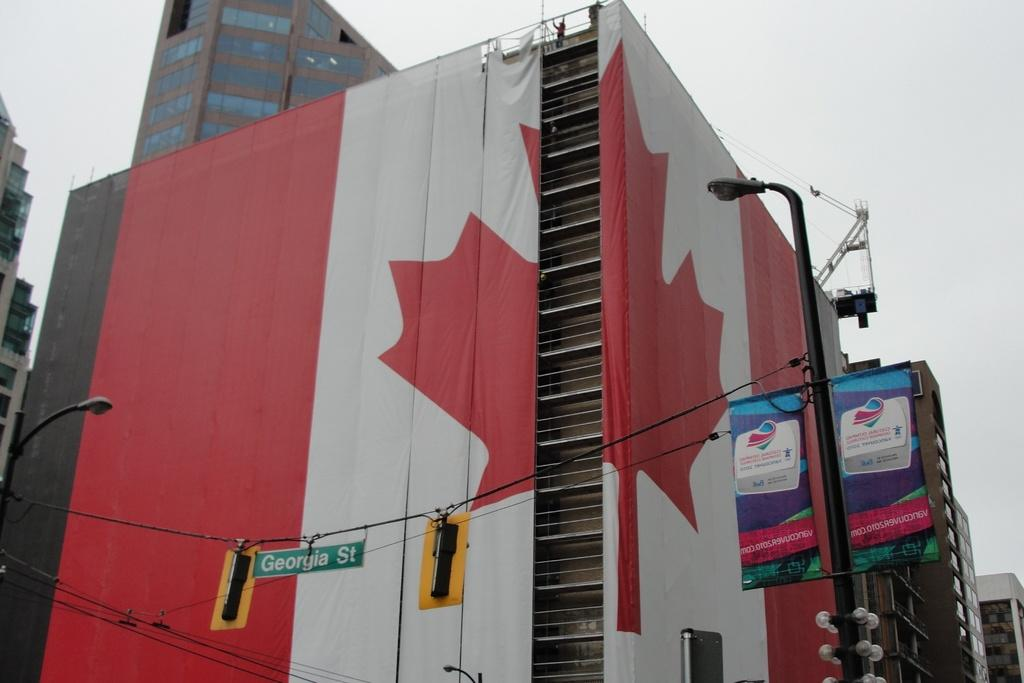<image>
Share a concise interpretation of the image provided. A multi-story building wrapped in two pieces of the Canadian flag in front of a red light on Georgia Street. 